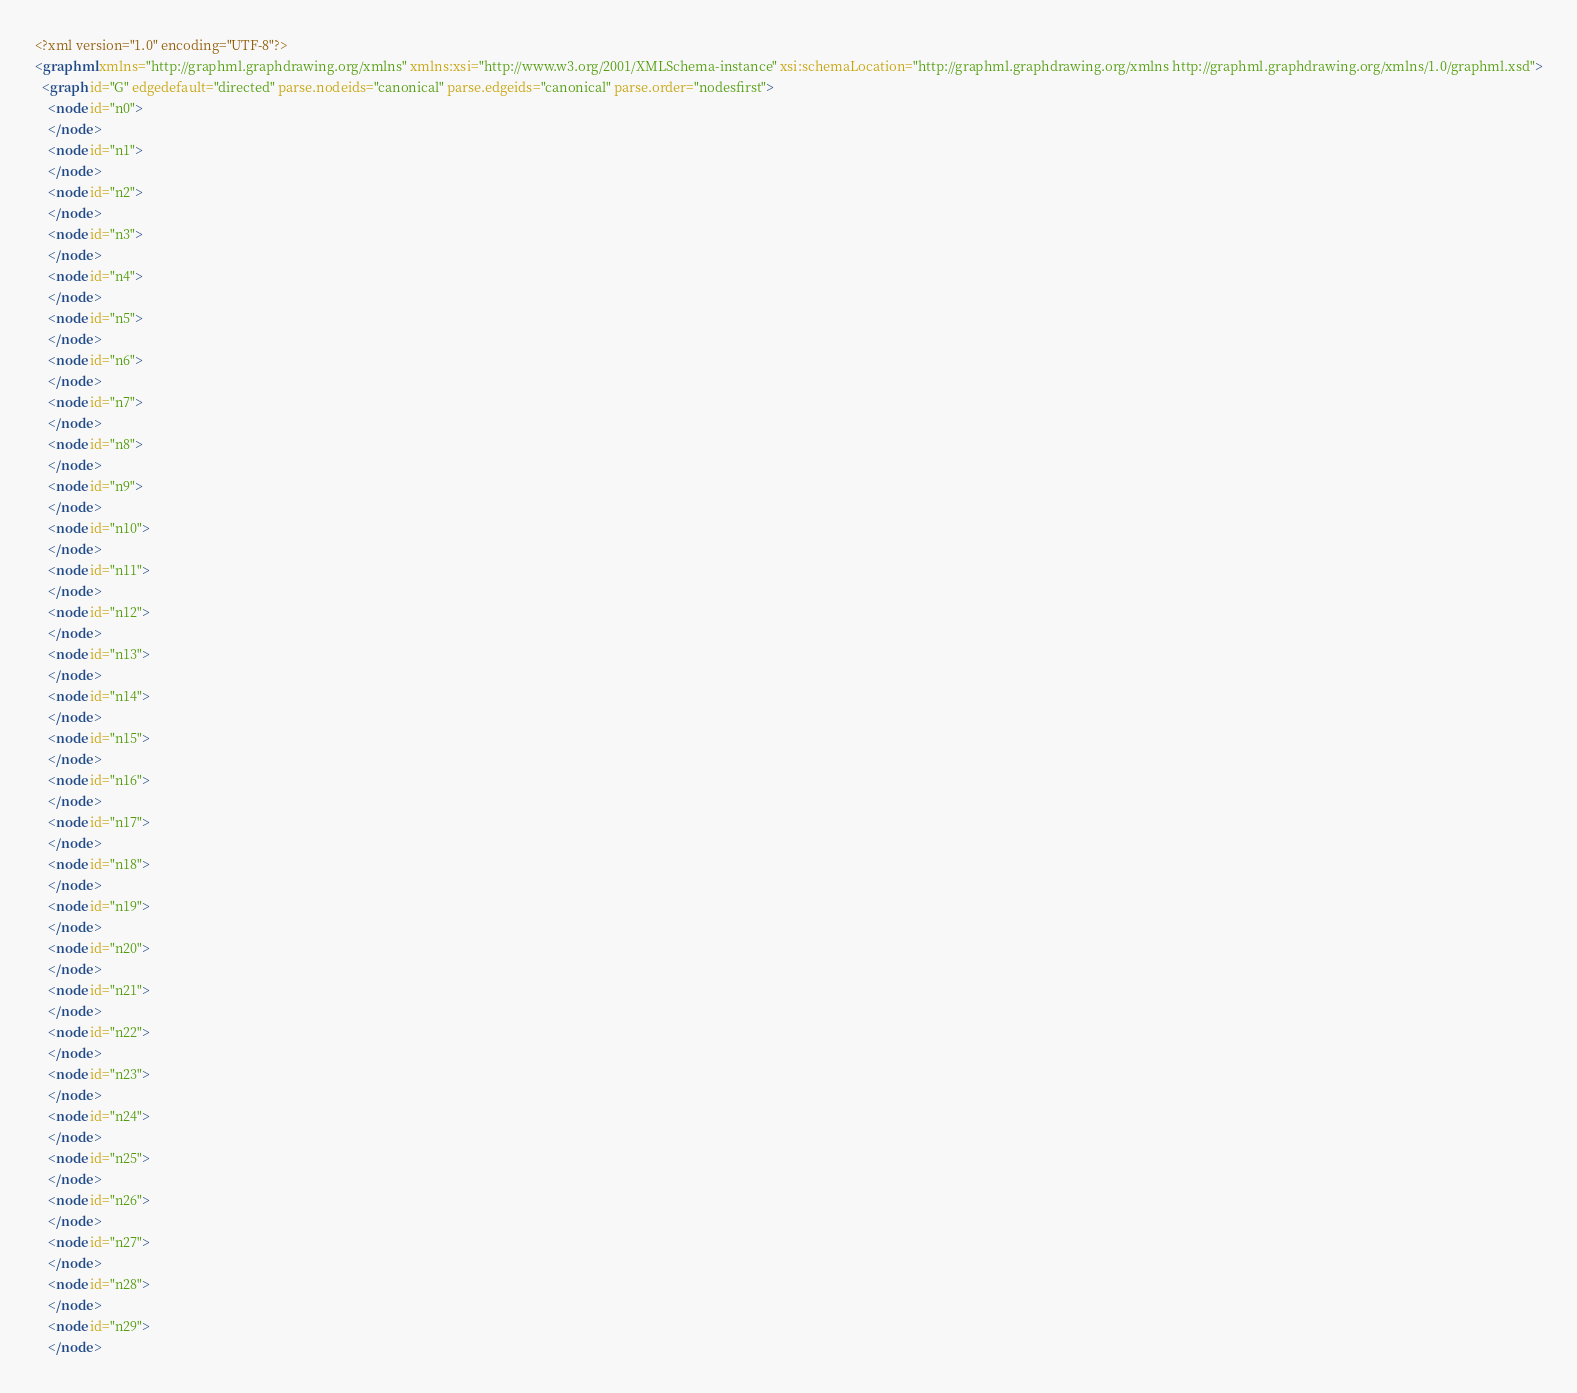<code> <loc_0><loc_0><loc_500><loc_500><_XML_><?xml version="1.0" encoding="UTF-8"?>
<graphml xmlns="http://graphml.graphdrawing.org/xmlns" xmlns:xsi="http://www.w3.org/2001/XMLSchema-instance" xsi:schemaLocation="http://graphml.graphdrawing.org/xmlns http://graphml.graphdrawing.org/xmlns/1.0/graphml.xsd">
  <graph id="G" edgedefault="directed" parse.nodeids="canonical" parse.edgeids="canonical" parse.order="nodesfirst">
    <node id="n0">
    </node>
    <node id="n1">
    </node>
    <node id="n2">
    </node>
    <node id="n3">
    </node>
    <node id="n4">
    </node>
    <node id="n5">
    </node>
    <node id="n6">
    </node>
    <node id="n7">
    </node>
    <node id="n8">
    </node>
    <node id="n9">
    </node>
    <node id="n10">
    </node>
    <node id="n11">
    </node>
    <node id="n12">
    </node>
    <node id="n13">
    </node>
    <node id="n14">
    </node>
    <node id="n15">
    </node>
    <node id="n16">
    </node>
    <node id="n17">
    </node>
    <node id="n18">
    </node>
    <node id="n19">
    </node>
    <node id="n20">
    </node>
    <node id="n21">
    </node>
    <node id="n22">
    </node>
    <node id="n23">
    </node>
    <node id="n24">
    </node>
    <node id="n25">
    </node>
    <node id="n26">
    </node>
    <node id="n27">
    </node>
    <node id="n28">
    </node>
    <node id="n29">
    </node></code> 